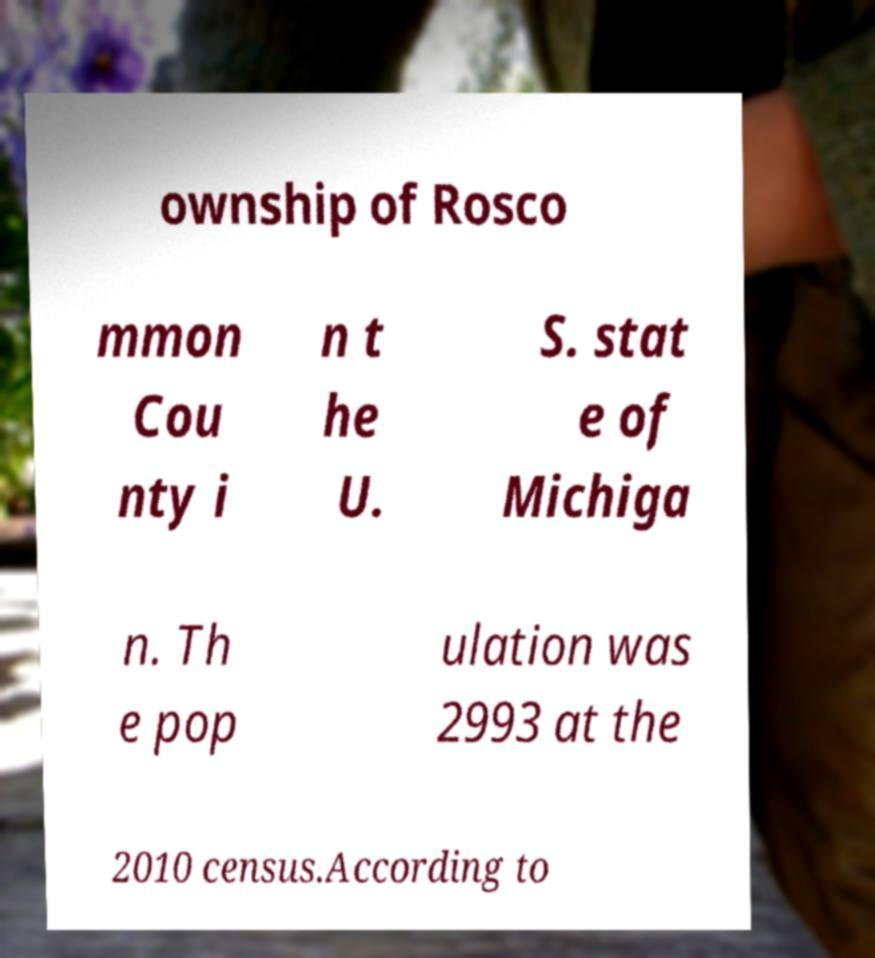Please identify and transcribe the text found in this image. ownship of Rosco mmon Cou nty i n t he U. S. stat e of Michiga n. Th e pop ulation was 2993 at the 2010 census.According to 